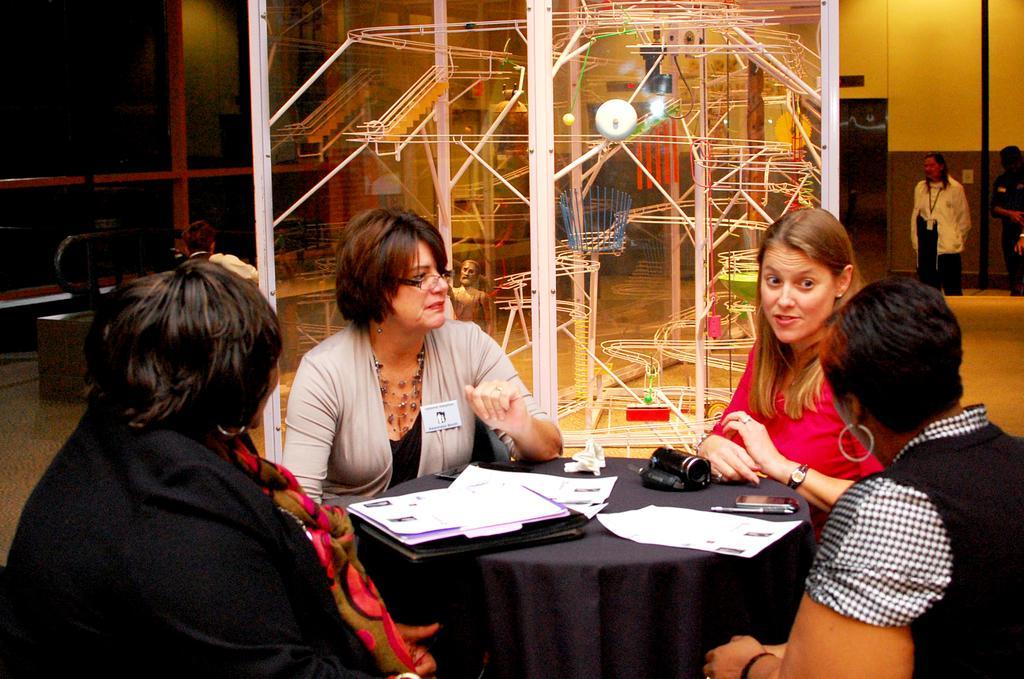How would you summarize this image in a sentence or two? In the image we can see there are people who are sitting on chair and in front of them there is a table on which there is a file and papers, mobile phone and video camera is kept. At the back there are iron machines and a man is standing over here. 